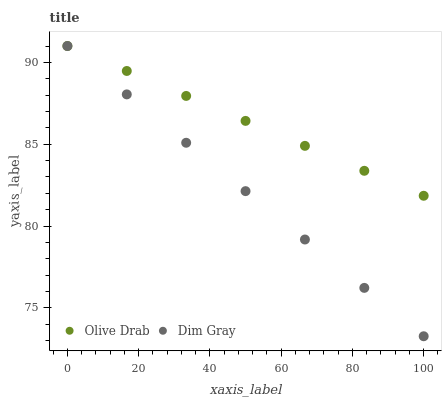Does Dim Gray have the minimum area under the curve?
Answer yes or no. Yes. Does Olive Drab have the maximum area under the curve?
Answer yes or no. Yes. Does Olive Drab have the minimum area under the curve?
Answer yes or no. No. Is Dim Gray the smoothest?
Answer yes or no. Yes. Is Olive Drab the roughest?
Answer yes or no. Yes. Is Olive Drab the smoothest?
Answer yes or no. No. Does Dim Gray have the lowest value?
Answer yes or no. Yes. Does Olive Drab have the lowest value?
Answer yes or no. No. Does Olive Drab have the highest value?
Answer yes or no. Yes. Does Dim Gray intersect Olive Drab?
Answer yes or no. Yes. Is Dim Gray less than Olive Drab?
Answer yes or no. No. Is Dim Gray greater than Olive Drab?
Answer yes or no. No. 